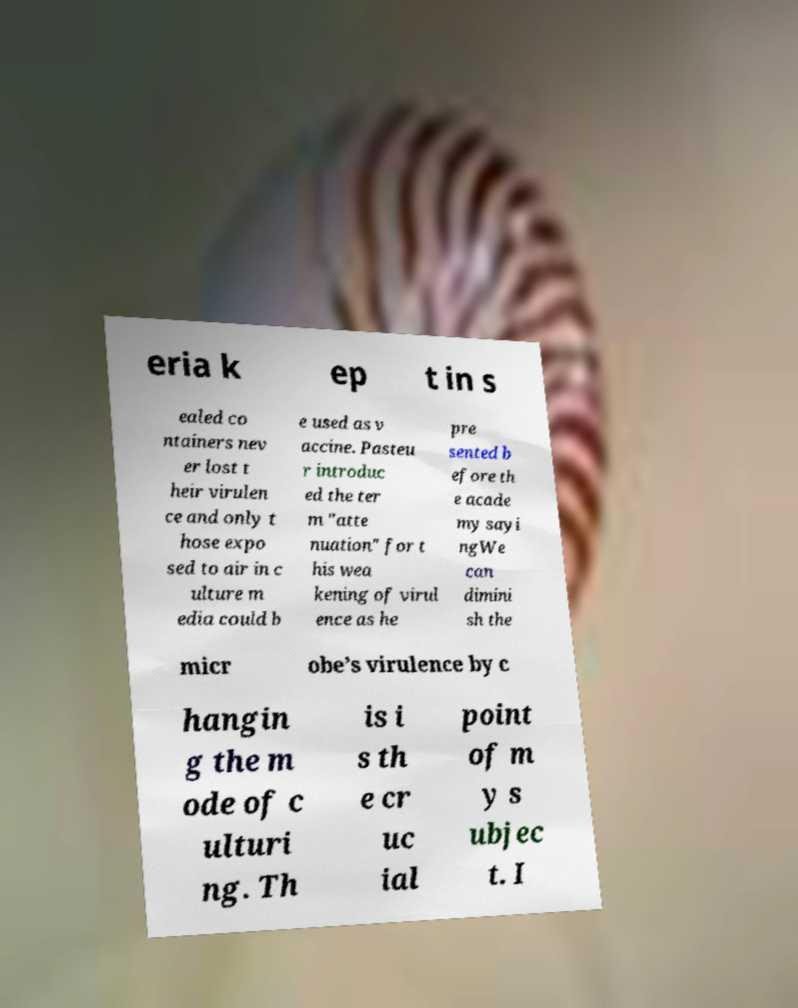Could you extract and type out the text from this image? eria k ep t in s ealed co ntainers nev er lost t heir virulen ce and only t hose expo sed to air in c ulture m edia could b e used as v accine. Pasteu r introduc ed the ter m "atte nuation" for t his wea kening of virul ence as he pre sented b efore th e acade my sayi ngWe can dimini sh the micr obe’s virulence by c hangin g the m ode of c ulturi ng. Th is i s th e cr uc ial point of m y s ubjec t. I 